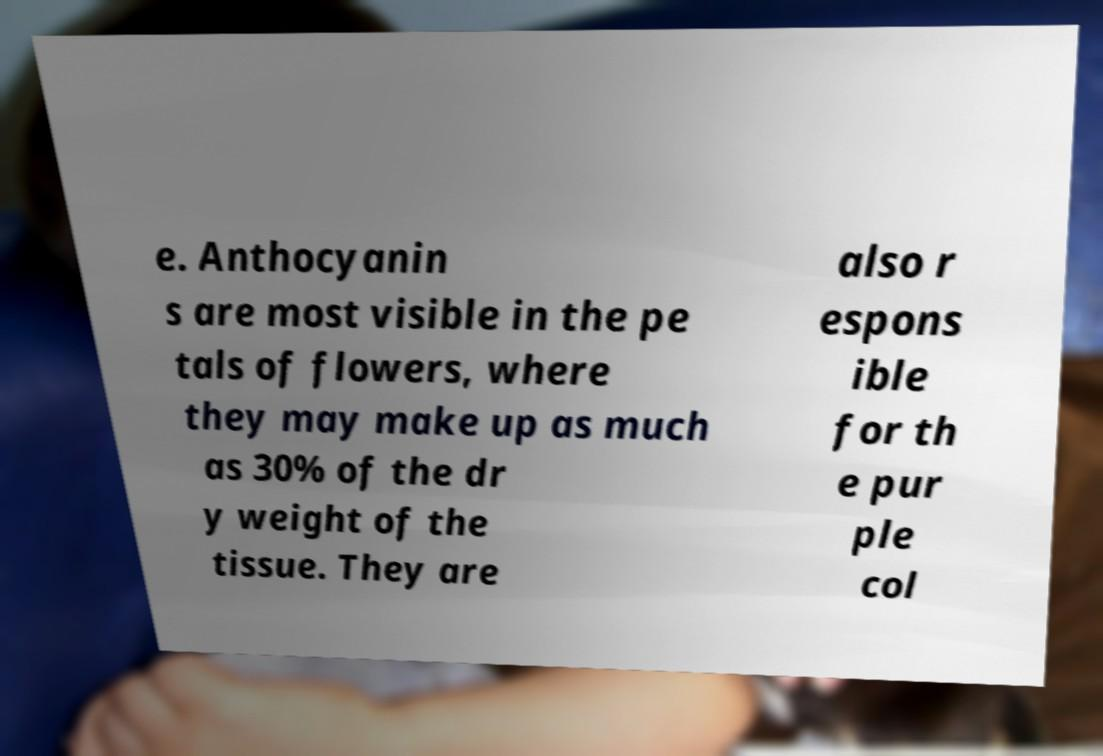There's text embedded in this image that I need extracted. Can you transcribe it verbatim? e. Anthocyanin s are most visible in the pe tals of flowers, where they may make up as much as 30% of the dr y weight of the tissue. They are also r espons ible for th e pur ple col 